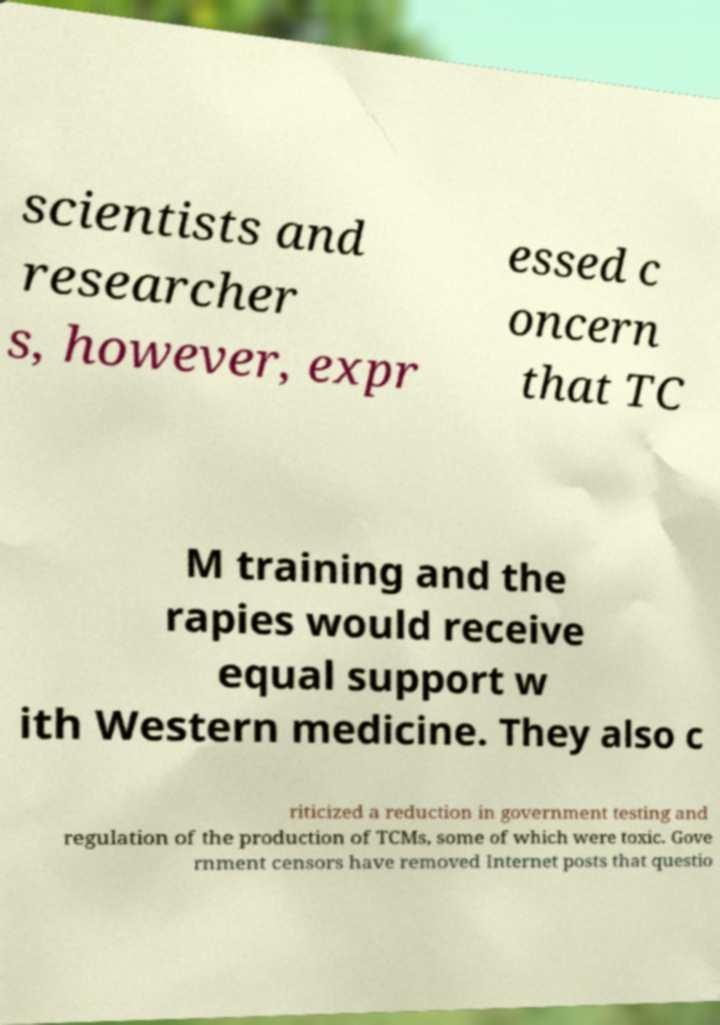Can you read and provide the text displayed in the image?This photo seems to have some interesting text. Can you extract and type it out for me? scientists and researcher s, however, expr essed c oncern that TC M training and the rapies would receive equal support w ith Western medicine. They also c riticized a reduction in government testing and regulation of the production of TCMs, some of which were toxic. Gove rnment censors have removed Internet posts that questio 